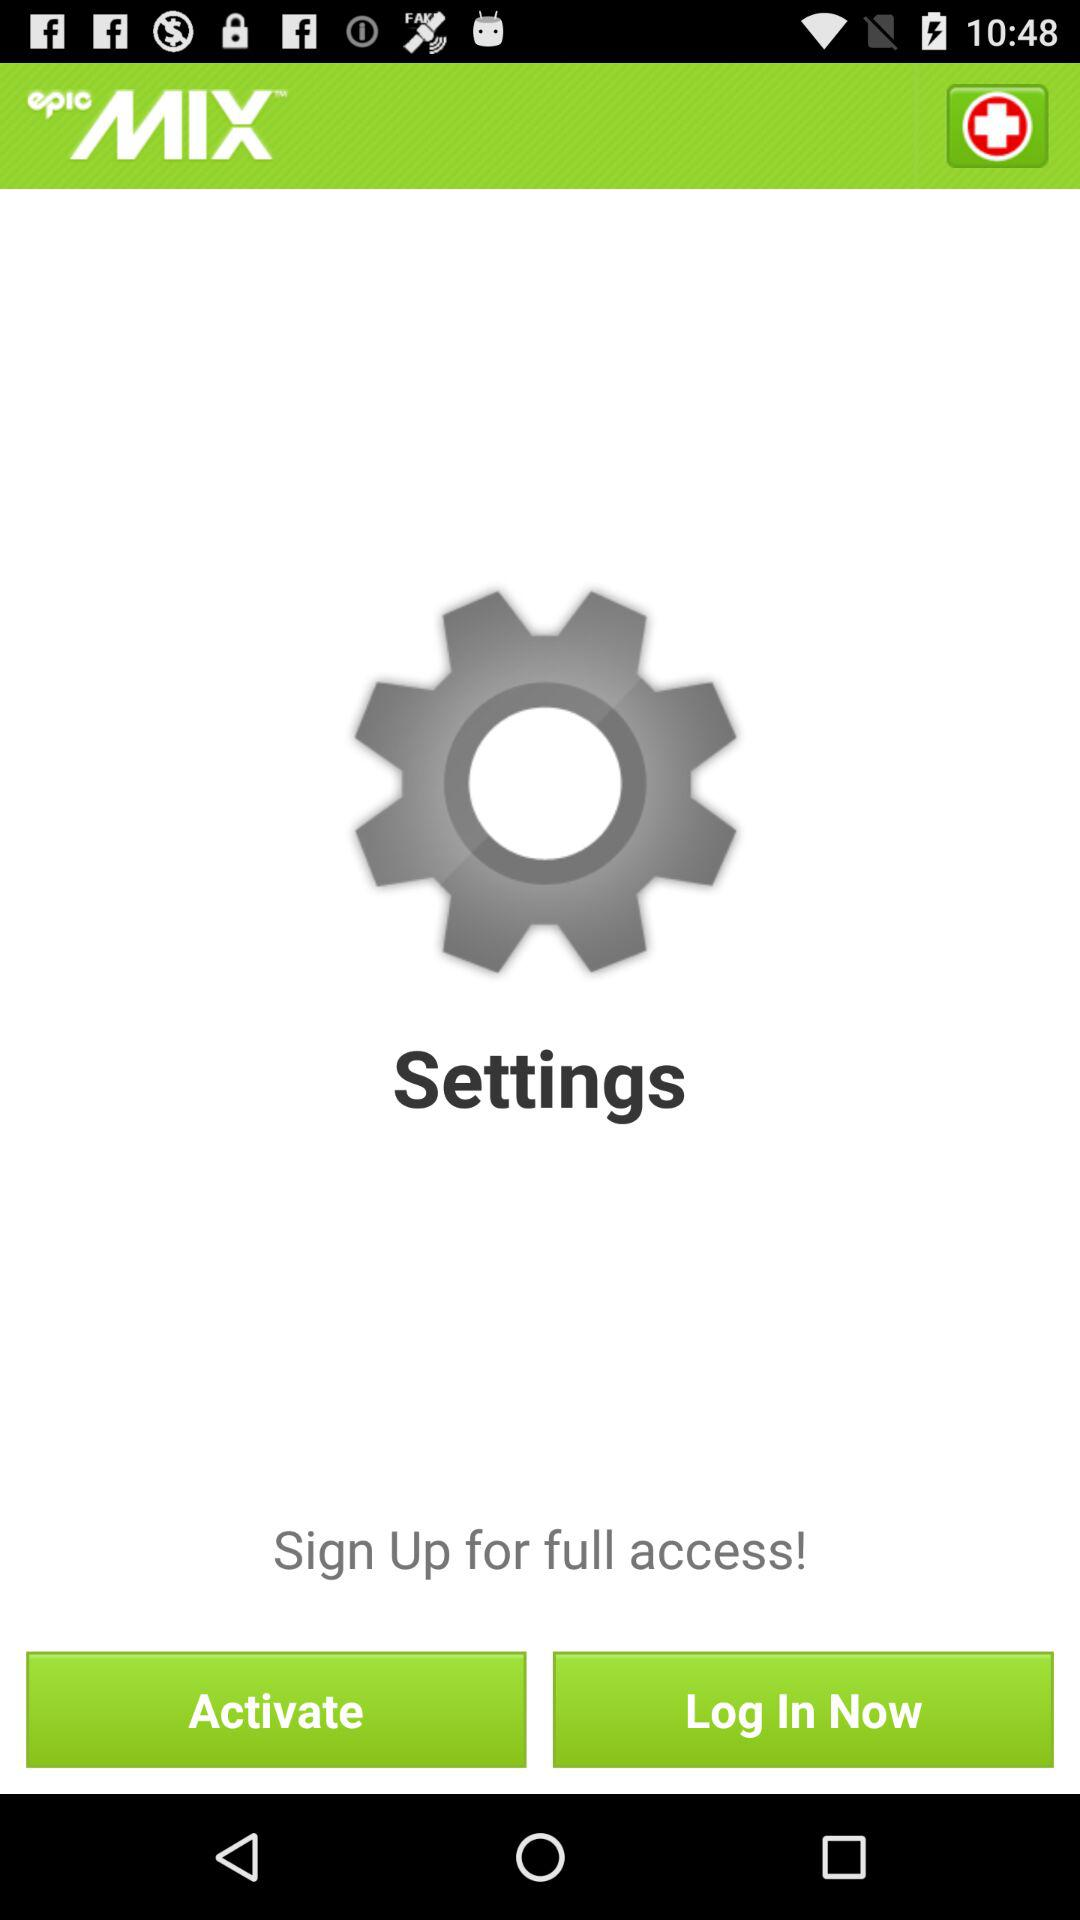What is the name of the application? The name of the application is "EpicMix". 